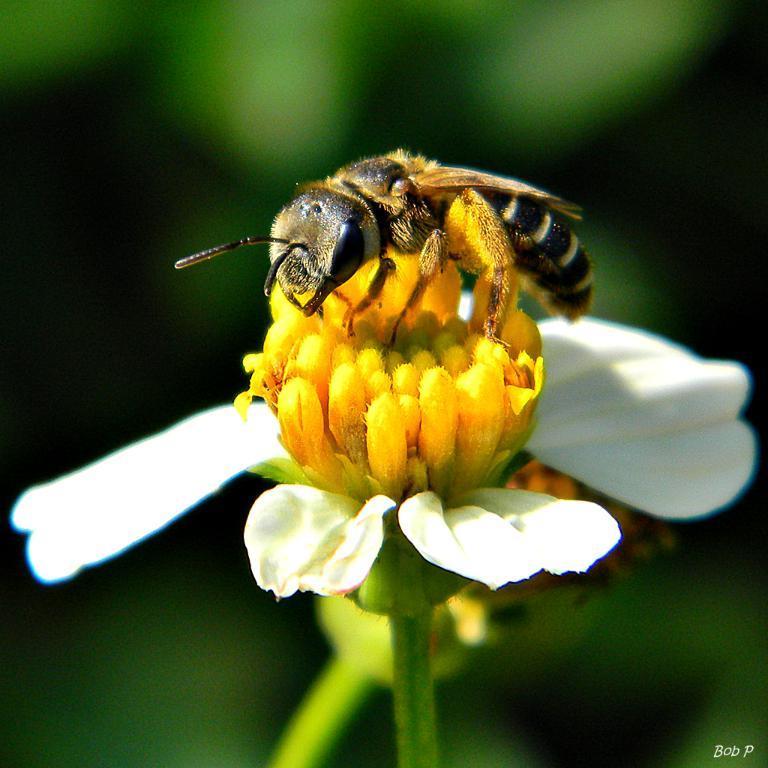Please provide a concise description of this image. In this image we can see an insect on the flower, there are white petals, the background is blurry. 